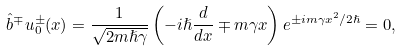Convert formula to latex. <formula><loc_0><loc_0><loc_500><loc_500>\hat { b } ^ { \mp } u ^ { \pm } _ { 0 } ( x ) = \frac { 1 } { \sqrt { 2 m \hslash \gamma } } \left ( - i \hslash \frac { d } { d x } \mp m \gamma x \right ) e ^ { \pm i m \gamma x ^ { 2 } / 2 \hslash } = 0 ,</formula> 